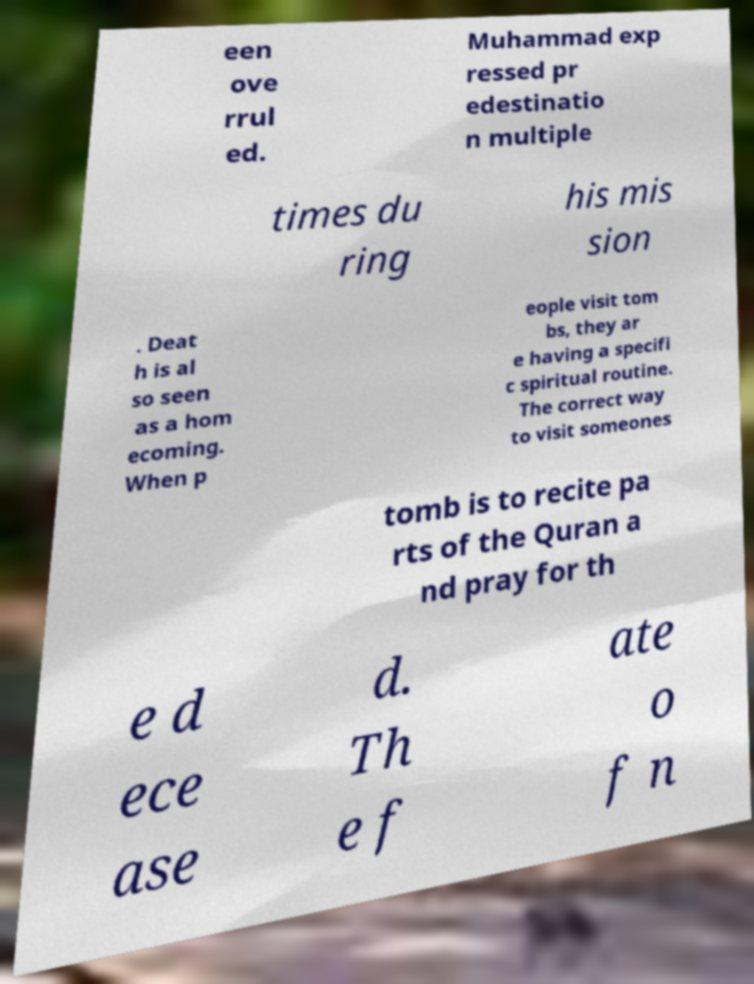Can you read and provide the text displayed in the image?This photo seems to have some interesting text. Can you extract and type it out for me? een ove rrul ed. Muhammad exp ressed pr edestinatio n multiple times du ring his mis sion . Deat h is al so seen as a hom ecoming. When p eople visit tom bs, they ar e having a specifi c spiritual routine. The correct way to visit someones tomb is to recite pa rts of the Quran a nd pray for th e d ece ase d. Th e f ate o f n 